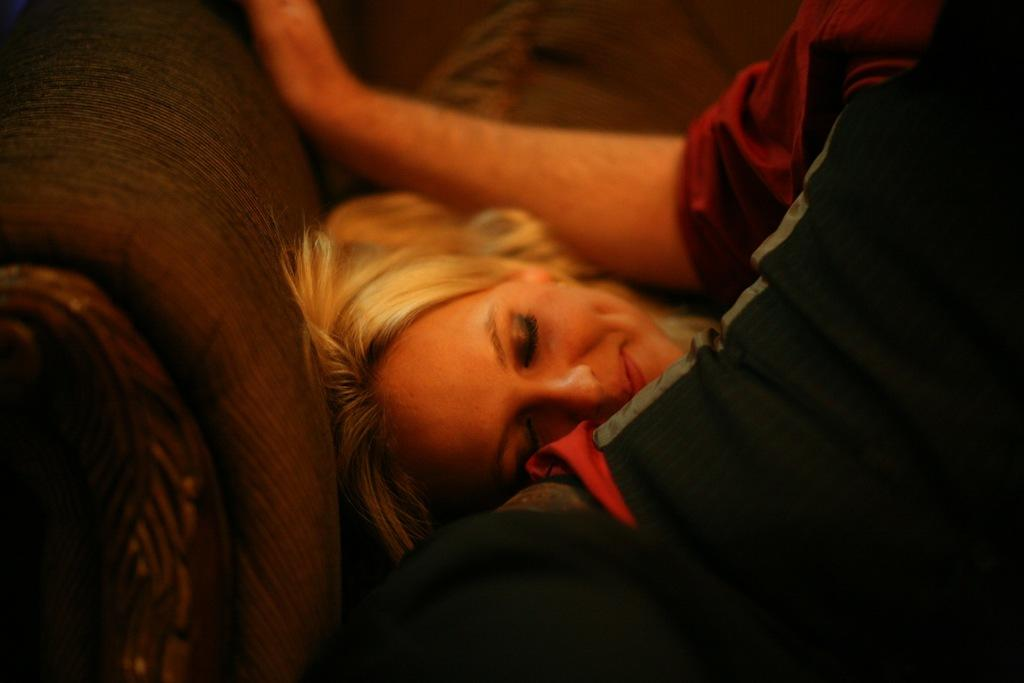What is the woman doing in the image? The woman is lying on a couch in the image. Who is with the woman in the image? There is a man sitting beside the woman in the image. What type of map is the woman holding in the image? There is no map present in the image; the woman is lying on a couch and the man is sitting beside her. 